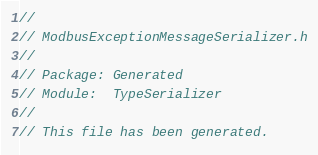<code> <loc_0><loc_0><loc_500><loc_500><_C_>//
// ModbusExceptionMessageSerializer.h
//
// Package: Generated
// Module:  TypeSerializer
//
// This file has been generated.</code> 